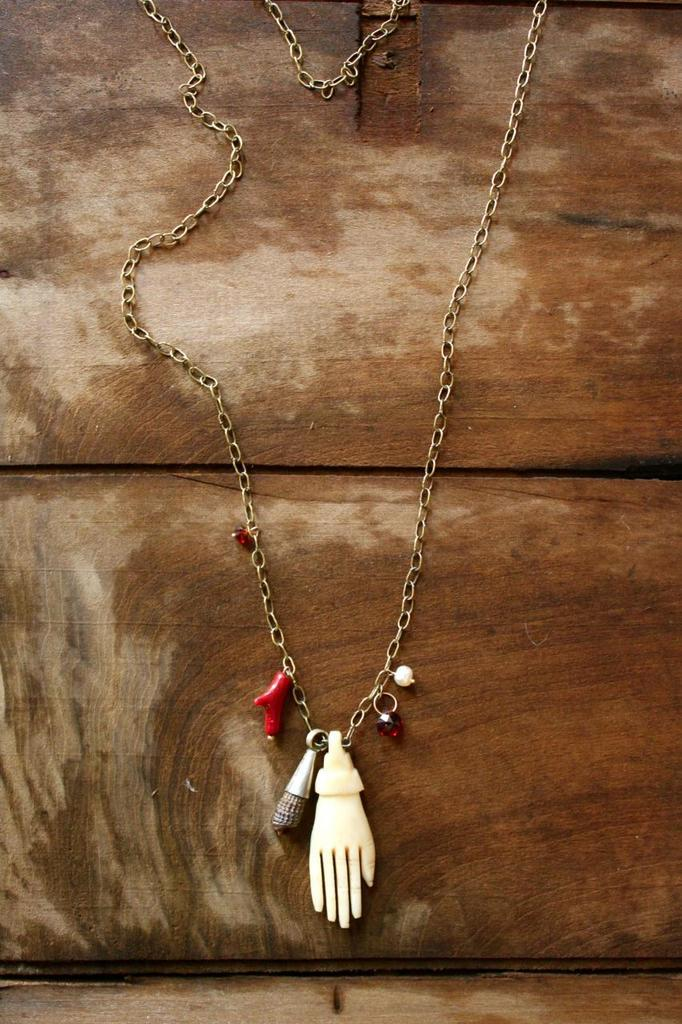What can be seen in the image that resembles a series of connected links? There is a chain in the image. What is connected to the chain? Objects are attached to the chain. On what type of surface is the chain placed? The chain is on a wooden surface. How many birds are perched on the chain in the image? There are no birds present in the image; it only features a chain with objects attached to it on a wooden surface. 